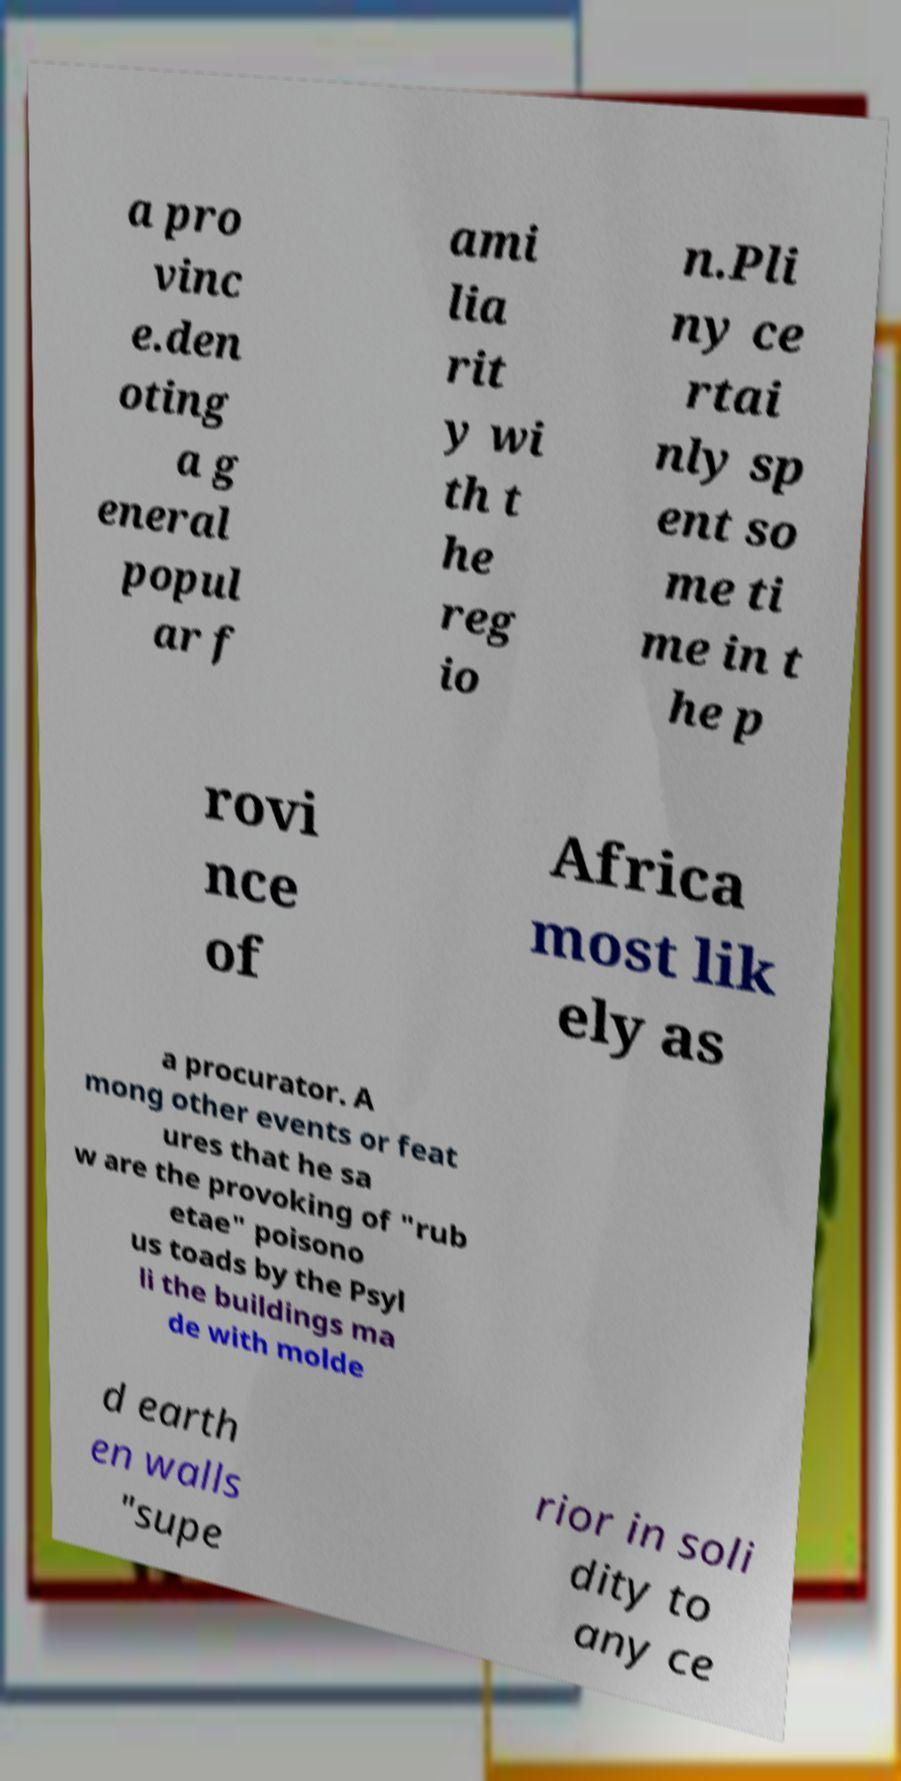I need the written content from this picture converted into text. Can you do that? a pro vinc e.den oting a g eneral popul ar f ami lia rit y wi th t he reg io n.Pli ny ce rtai nly sp ent so me ti me in t he p rovi nce of Africa most lik ely as a procurator. A mong other events or feat ures that he sa w are the provoking of "rub etae" poisono us toads by the Psyl li the buildings ma de with molde d earth en walls "supe rior in soli dity to any ce 